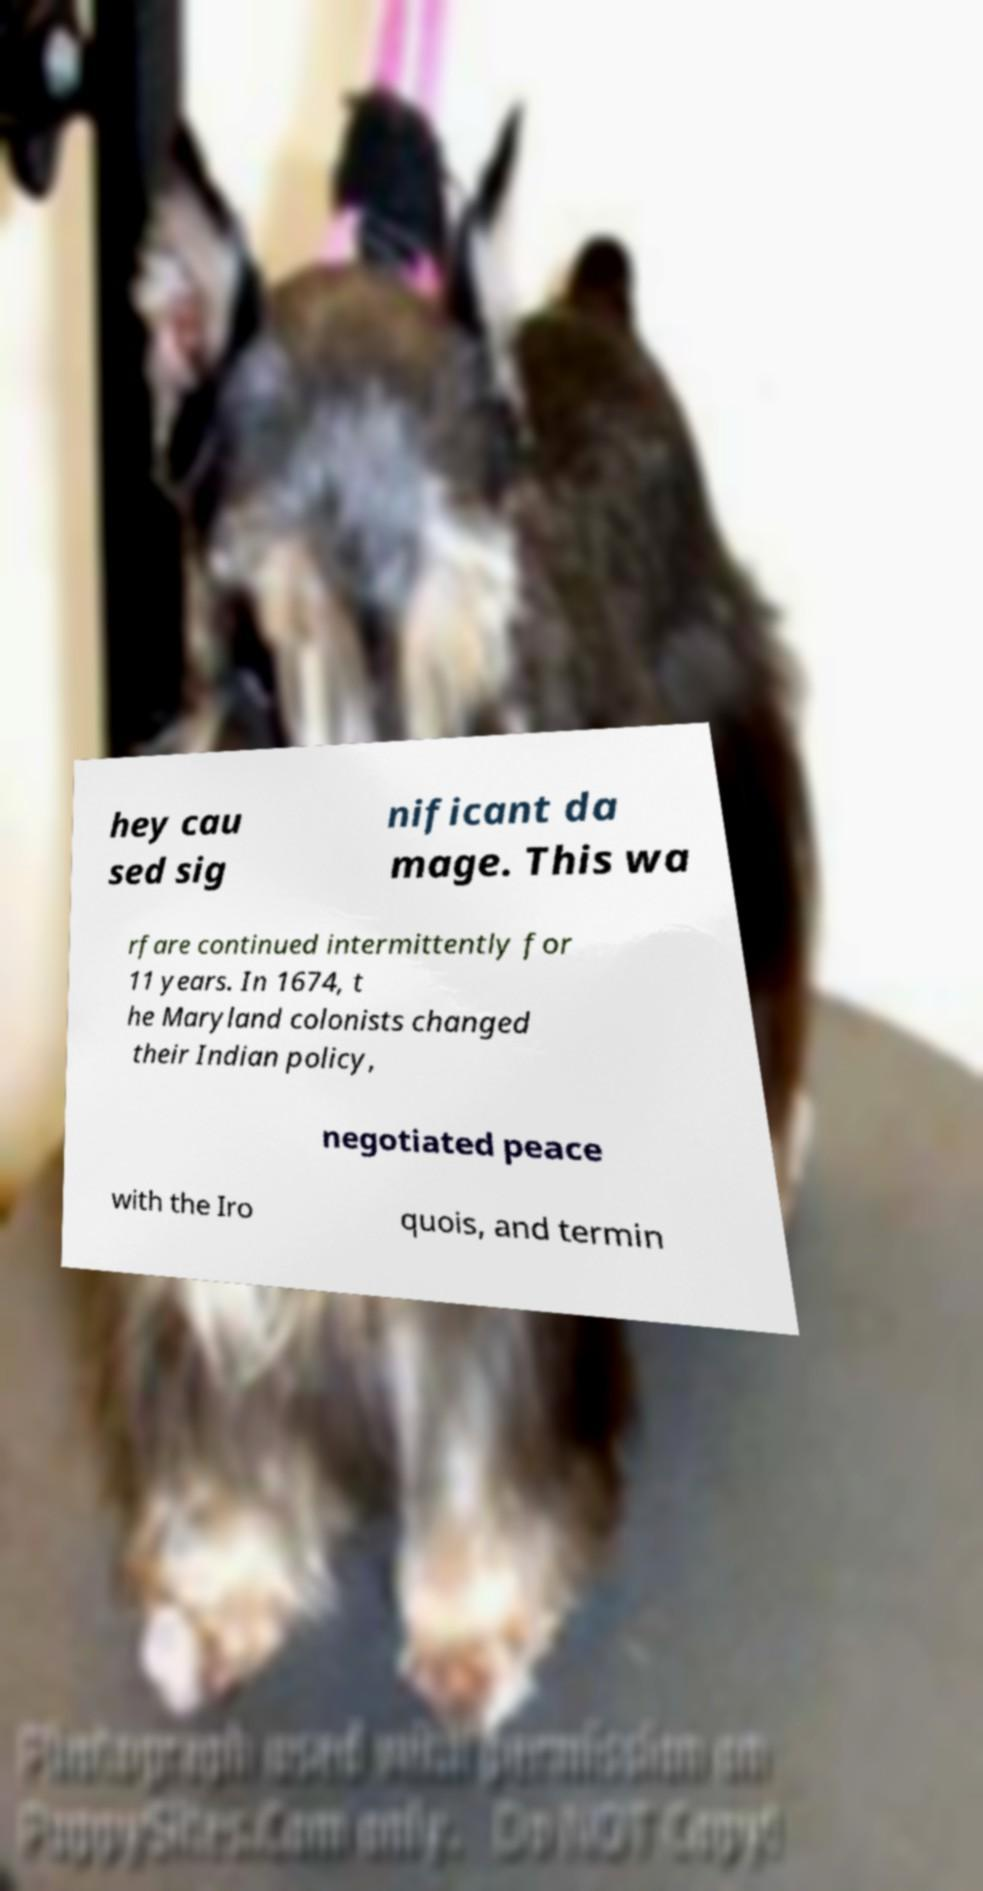Can you read and provide the text displayed in the image?This photo seems to have some interesting text. Can you extract and type it out for me? hey cau sed sig nificant da mage. This wa rfare continued intermittently for 11 years. In 1674, t he Maryland colonists changed their Indian policy, negotiated peace with the Iro quois, and termin 